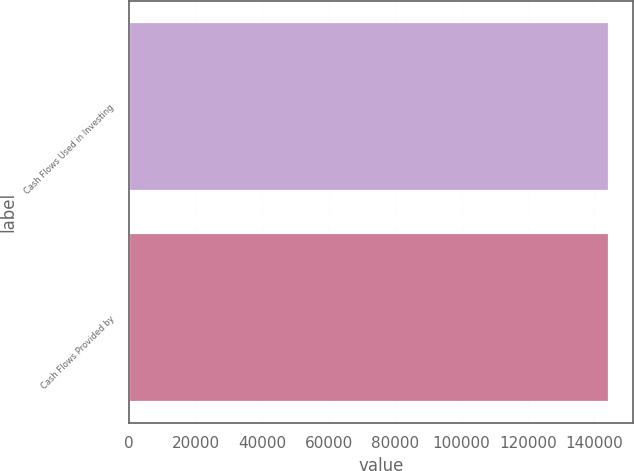Convert chart to OTSL. <chart><loc_0><loc_0><loc_500><loc_500><bar_chart><fcel>Cash Flows Used in Investing<fcel>Cash Flows Provided by<nl><fcel>144360<fcel>144360<nl></chart> 